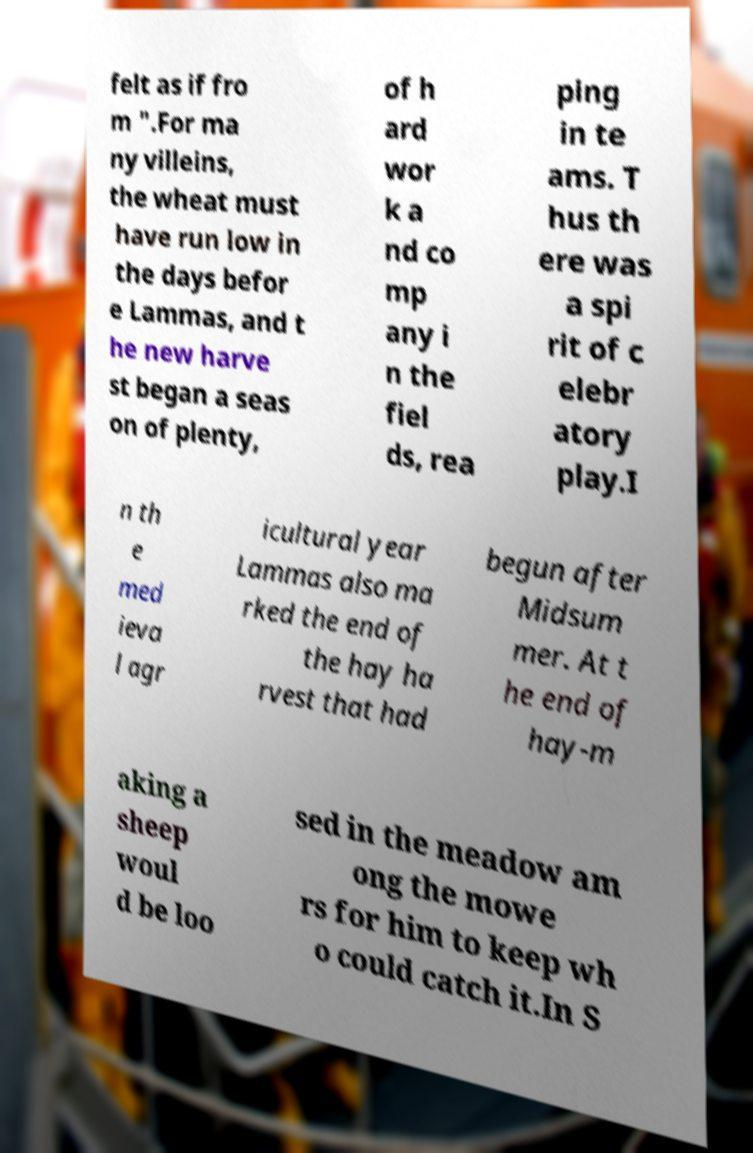Could you extract and type out the text from this image? felt as if fro m ".For ma ny villeins, the wheat must have run low in the days befor e Lammas, and t he new harve st began a seas on of plenty, of h ard wor k a nd co mp any i n the fiel ds, rea ping in te ams. T hus th ere was a spi rit of c elebr atory play.I n th e med ieva l agr icultural year Lammas also ma rked the end of the hay ha rvest that had begun after Midsum mer. At t he end of hay-m aking a sheep woul d be loo sed in the meadow am ong the mowe rs for him to keep wh o could catch it.In S 